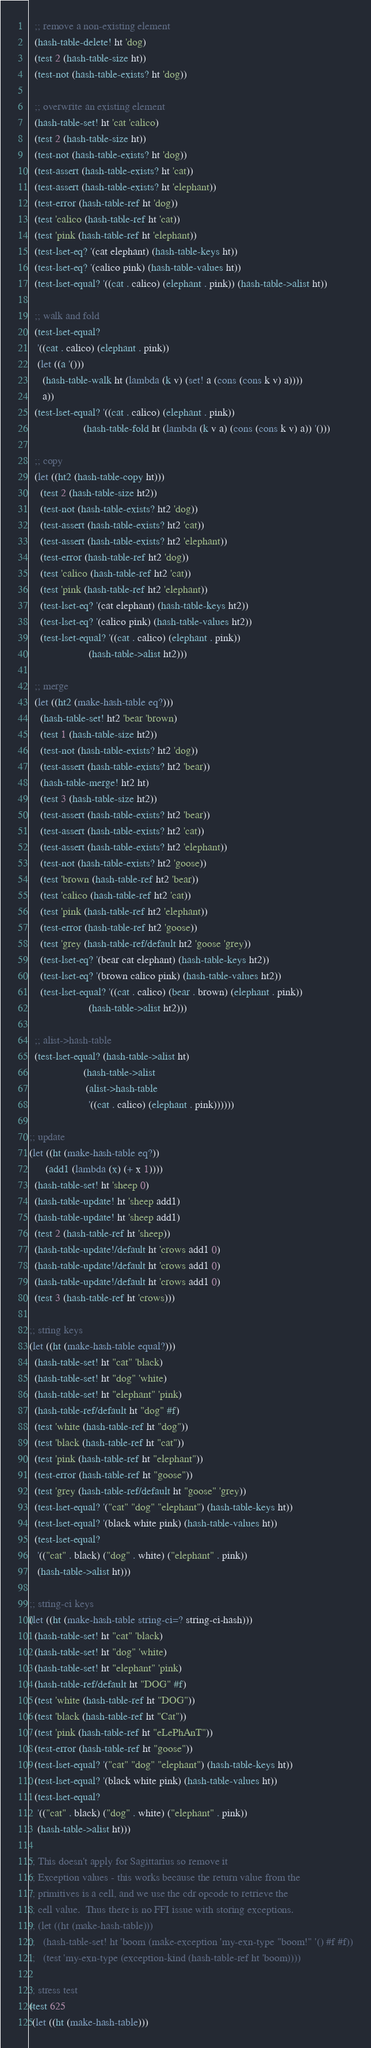Convert code to text. <code><loc_0><loc_0><loc_500><loc_500><_Scheme_>  ;; remove a non-existing element
  (hash-table-delete! ht 'dog)
  (test 2 (hash-table-size ht))
  (test-not (hash-table-exists? ht 'dog))

  ;; overwrite an existing element
  (hash-table-set! ht 'cat 'calico)
  (test 2 (hash-table-size ht))
  (test-not (hash-table-exists? ht 'dog))
  (test-assert (hash-table-exists? ht 'cat))
  (test-assert (hash-table-exists? ht 'elephant))
  (test-error (hash-table-ref ht 'dog))
  (test 'calico (hash-table-ref ht 'cat))
  (test 'pink (hash-table-ref ht 'elephant))
  (test-lset-eq? '(cat elephant) (hash-table-keys ht))
  (test-lset-eq? '(calico pink) (hash-table-values ht))
  (test-lset-equal? '((cat . calico) (elephant . pink)) (hash-table->alist ht))

  ;; walk and fold
  (test-lset-equal?
   '((cat . calico) (elephant . pink))
   (let ((a '()))
     (hash-table-walk ht (lambda (k v) (set! a (cons (cons k v) a))))
     a))
  (test-lset-equal? '((cat . calico) (elephant . pink))
                    (hash-table-fold ht (lambda (k v a) (cons (cons k v) a)) '()))

  ;; copy
  (let ((ht2 (hash-table-copy ht)))
    (test 2 (hash-table-size ht2))
    (test-not (hash-table-exists? ht2 'dog))
    (test-assert (hash-table-exists? ht2 'cat))
    (test-assert (hash-table-exists? ht2 'elephant))
    (test-error (hash-table-ref ht2 'dog))
    (test 'calico (hash-table-ref ht2 'cat))
    (test 'pink (hash-table-ref ht2 'elephant))
    (test-lset-eq? '(cat elephant) (hash-table-keys ht2))
    (test-lset-eq? '(calico pink) (hash-table-values ht2))
    (test-lset-equal? '((cat . calico) (elephant . pink))
                      (hash-table->alist ht2)))

  ;; merge
  (let ((ht2 (make-hash-table eq?)))
    (hash-table-set! ht2 'bear 'brown)
    (test 1 (hash-table-size ht2))
    (test-not (hash-table-exists? ht2 'dog))
    (test-assert (hash-table-exists? ht2 'bear))
    (hash-table-merge! ht2 ht)
    (test 3 (hash-table-size ht2))
    (test-assert (hash-table-exists? ht2 'bear))
    (test-assert (hash-table-exists? ht2 'cat))
    (test-assert (hash-table-exists? ht2 'elephant))
    (test-not (hash-table-exists? ht2 'goose))
    (test 'brown (hash-table-ref ht2 'bear))
    (test 'calico (hash-table-ref ht2 'cat))
    (test 'pink (hash-table-ref ht2 'elephant))
    (test-error (hash-table-ref ht2 'goose))
    (test 'grey (hash-table-ref/default ht2 'goose 'grey))
    (test-lset-eq? '(bear cat elephant) (hash-table-keys ht2))
    (test-lset-eq? '(brown calico pink) (hash-table-values ht2))
    (test-lset-equal? '((cat . calico) (bear . brown) (elephant . pink))
                      (hash-table->alist ht2)))

  ;; alist->hash-table
  (test-lset-equal? (hash-table->alist ht)
                    (hash-table->alist
                     (alist->hash-table
                      '((cat . calico) (elephant . pink))))))

;; update
(let ((ht (make-hash-table eq?))
      (add1 (lambda (x) (+ x 1))))
  (hash-table-set! ht 'sheep 0)
  (hash-table-update! ht 'sheep add1)
  (hash-table-update! ht 'sheep add1)
  (test 2 (hash-table-ref ht 'sheep))
  (hash-table-update!/default ht 'crows add1 0)
  (hash-table-update!/default ht 'crows add1 0)
  (hash-table-update!/default ht 'crows add1 0)
  (test 3 (hash-table-ref ht 'crows)))

;; string keys
(let ((ht (make-hash-table equal?)))
  (hash-table-set! ht "cat" 'black)
  (hash-table-set! ht "dog" 'white)
  (hash-table-set! ht "elephant" 'pink)
  (hash-table-ref/default ht "dog" #f)
  (test 'white (hash-table-ref ht "dog"))
  (test 'black (hash-table-ref ht "cat"))
  (test 'pink (hash-table-ref ht "elephant"))
  (test-error (hash-table-ref ht "goose"))
  (test 'grey (hash-table-ref/default ht "goose" 'grey))
  (test-lset-equal? '("cat" "dog" "elephant") (hash-table-keys ht))
  (test-lset-equal? '(black white pink) (hash-table-values ht))
  (test-lset-equal?
   '(("cat" . black) ("dog" . white) ("elephant" . pink))
   (hash-table->alist ht)))

;; string-ci keys
(let ((ht (make-hash-table string-ci=? string-ci-hash)))
  (hash-table-set! ht "cat" 'black)
  (hash-table-set! ht "dog" 'white)
  (hash-table-set! ht "elephant" 'pink)
  (hash-table-ref/default ht "DOG" #f)
  (test 'white (hash-table-ref ht "DOG"))
  (test 'black (hash-table-ref ht "Cat"))
  (test 'pink (hash-table-ref ht "eLePhAnT"))
  (test-error (hash-table-ref ht "goose"))
  (test-lset-equal? '("cat" "dog" "elephant") (hash-table-keys ht))
  (test-lset-equal? '(black white pink) (hash-table-values ht))
  (test-lset-equal?
   '(("cat" . black) ("dog" . white) ("elephant" . pink))
   (hash-table->alist ht)))

;; This doesn't apply for Sagittarius so remove it
;; Exception values - this works because the return value from the
;; primitives is a cell, and we use the cdr opcode to retrieve the
;; cell value.  Thus there is no FFI issue with storing exceptions.
;; (let ((ht (make-hash-table)))
;;   (hash-table-set! ht 'boom (make-exception 'my-exn-type "boom!" '() #f #f))
;;   (test 'my-exn-type (exception-kind (hash-table-ref ht 'boom))))

;; stress test
(test 625
 (let ((ht (make-hash-table)))</code> 